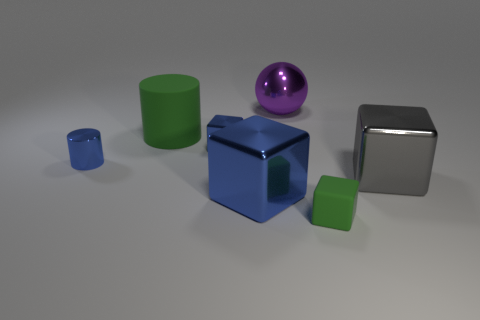Is there anything else that is the same shape as the large gray metallic object?
Provide a succinct answer. Yes. Are there any matte balls?
Your response must be concise. No. There is a matte thing that is in front of the blue metallic cylinder; is it the same size as the metallic block on the right side of the large purple shiny thing?
Offer a terse response. No. What is the big thing that is both behind the gray metallic block and in front of the ball made of?
Offer a very short reply. Rubber. What number of tiny things are on the right side of the small rubber cube?
Provide a short and direct response. 0. The small cylinder that is made of the same material as the ball is what color?
Make the answer very short. Blue. Is the gray thing the same shape as the large purple shiny object?
Give a very brief answer. No. What number of things are left of the green matte cylinder and behind the tiny blue metallic cube?
Keep it short and to the point. 0. What number of shiny objects are either large brown objects or blocks?
Give a very brief answer. 3. There is a blue cube that is behind the gray metallic thing that is in front of the big cylinder; what is its size?
Give a very brief answer. Small. 